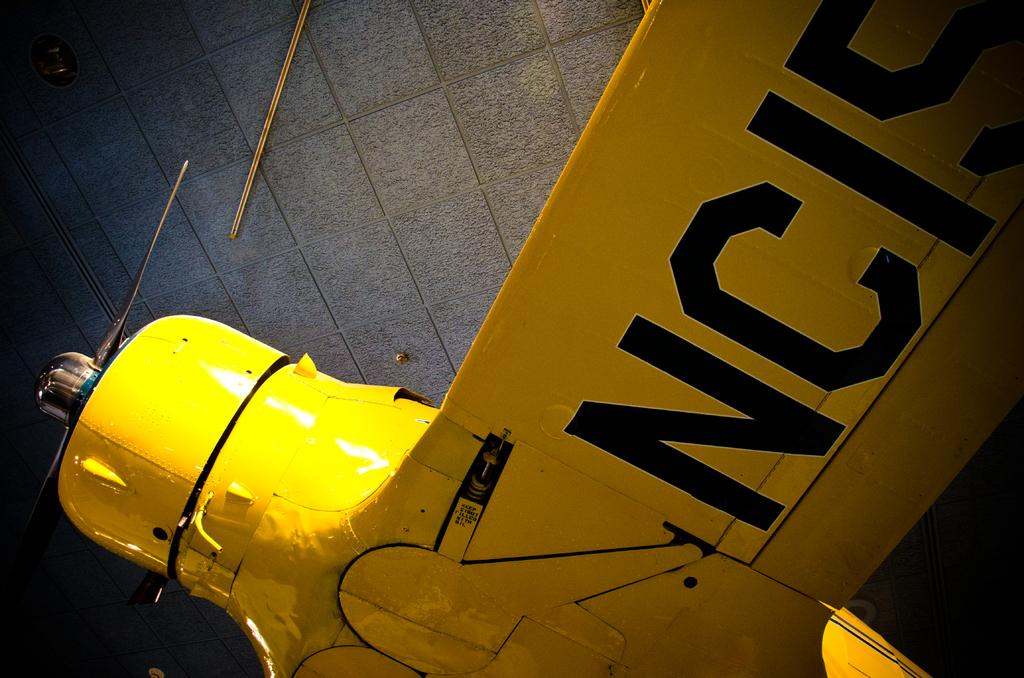<image>
Present a compact description of the photo's key features. a yellow sign with NC19 on the side of it 